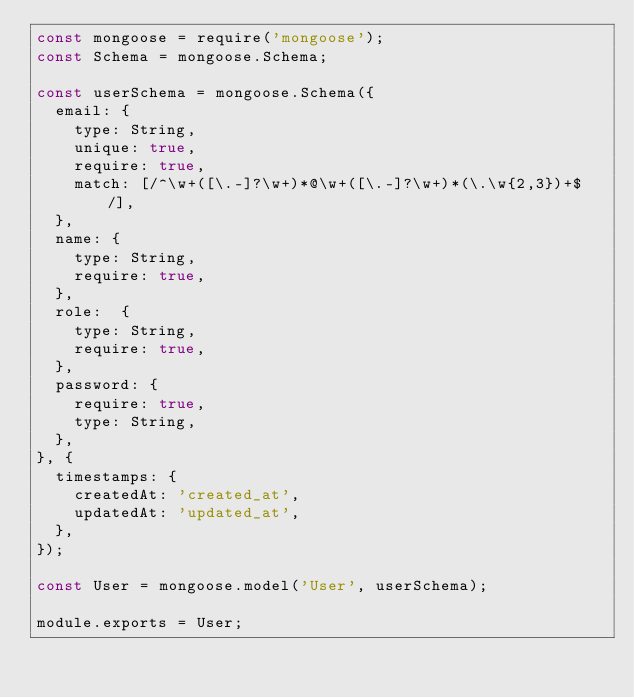<code> <loc_0><loc_0><loc_500><loc_500><_JavaScript_>const mongoose = require('mongoose');
const Schema = mongoose.Schema;

const userSchema = mongoose.Schema({
  email: {
    type: String,
    unique: true,
    require: true,
    match: [/^\w+([\.-]?\w+)*@\w+([\.-]?\w+)*(\.\w{2,3})+$/],
  },
  name: {
    type: String,
    require: true,
  },
  role:  {
    type: String,
    require: true,
  },
  password: {
    require: true,
    type: String,
  },
}, {
  timestamps: {
    createdAt: 'created_at',
    updatedAt: 'updated_at',
  },
});

const User = mongoose.model('User', userSchema);

module.exports = User;
</code> 